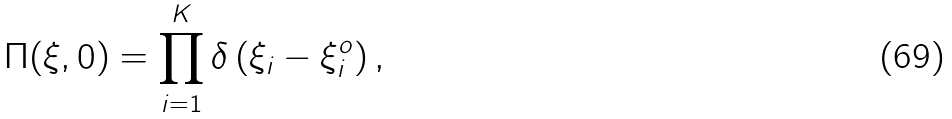<formula> <loc_0><loc_0><loc_500><loc_500>\Pi ( \xi , 0 ) = \prod _ { i = 1 } ^ { K } \delta \left ( \xi _ { i } - \xi _ { i } ^ { o } \right ) ,</formula> 